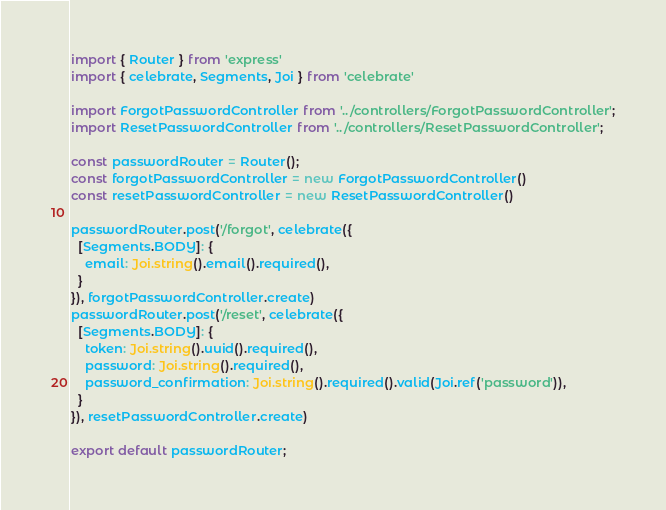Convert code to text. <code><loc_0><loc_0><loc_500><loc_500><_TypeScript_>import { Router } from 'express'
import { celebrate, Segments, Joi } from 'celebrate'

import ForgotPasswordController from '../controllers/ForgotPasswordController';
import ResetPasswordController from '../controllers/ResetPasswordController';

const passwordRouter = Router();
const forgotPasswordController = new ForgotPasswordController()
const resetPasswordController = new ResetPasswordController()

passwordRouter.post('/forgot', celebrate({
  [Segments.BODY]: {
    email: Joi.string().email().required(),
  }
}), forgotPasswordController.create)
passwordRouter.post('/reset', celebrate({
  [Segments.BODY]: {
    token: Joi.string().uuid().required(),
    password: Joi.string().required(),
    password_confirmation: Joi.string().required().valid(Joi.ref('password')),
  }
}), resetPasswordController.create)

export default passwordRouter;
</code> 